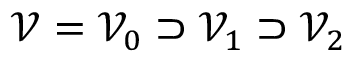Convert formula to latex. <formula><loc_0><loc_0><loc_500><loc_500>\mathcal { V } = \mathcal { V } _ { 0 } \supset \mathcal { V } _ { 1 } \supset \mathcal { V } _ { 2 }</formula> 